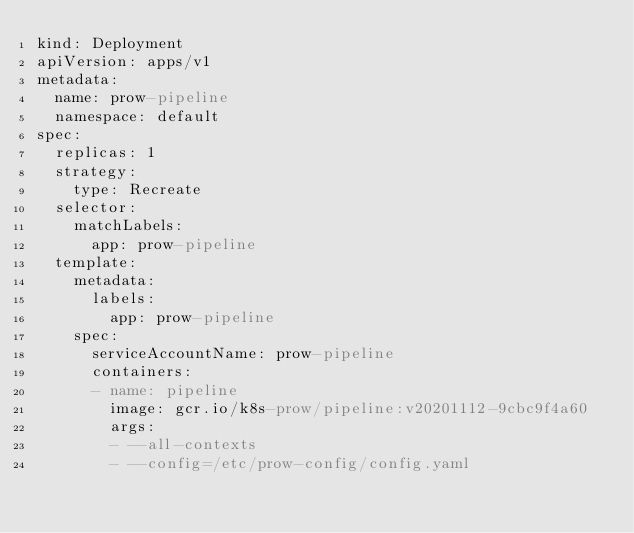<code> <loc_0><loc_0><loc_500><loc_500><_YAML_>kind: Deployment
apiVersion: apps/v1
metadata:
  name: prow-pipeline
  namespace: default
spec:
  replicas: 1
  strategy:
    type: Recreate
  selector:
    matchLabels:
      app: prow-pipeline
  template:
    metadata:
      labels:
        app: prow-pipeline
    spec:
      serviceAccountName: prow-pipeline
      containers:
      - name: pipeline
        image: gcr.io/k8s-prow/pipeline:v20201112-9cbc9f4a60
        args:
        - --all-contexts
        - --config=/etc/prow-config/config.yaml</code> 